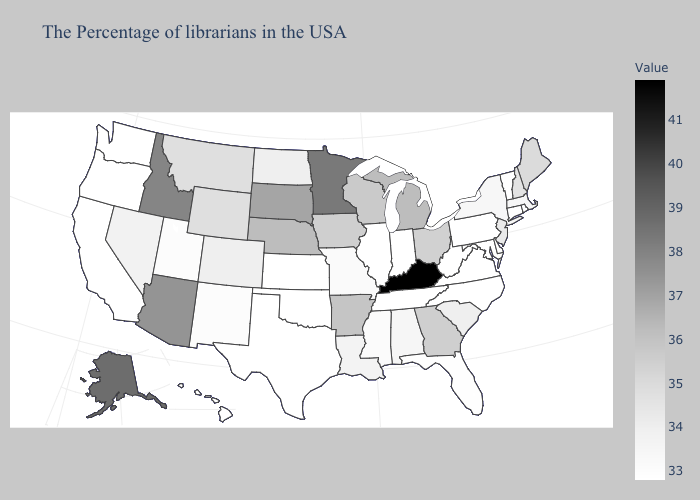Does the map have missing data?
Quick response, please. No. Does Mississippi have the lowest value in the USA?
Be succinct. No. Does Massachusetts have the lowest value in the Northeast?
Concise answer only. No. Which states have the lowest value in the USA?
Answer briefly. Rhode Island, Vermont, Connecticut, Delaware, Maryland, Pennsylvania, Virginia, North Carolina, West Virginia, Indiana, Tennessee, Illinois, Kansas, Oklahoma, Texas, California, Washington, Oregon, Hawaii. Among the states that border Delaware , does New Jersey have the highest value?
Quick response, please. Yes. Does Kentucky have the lowest value in the USA?
Concise answer only. No. 